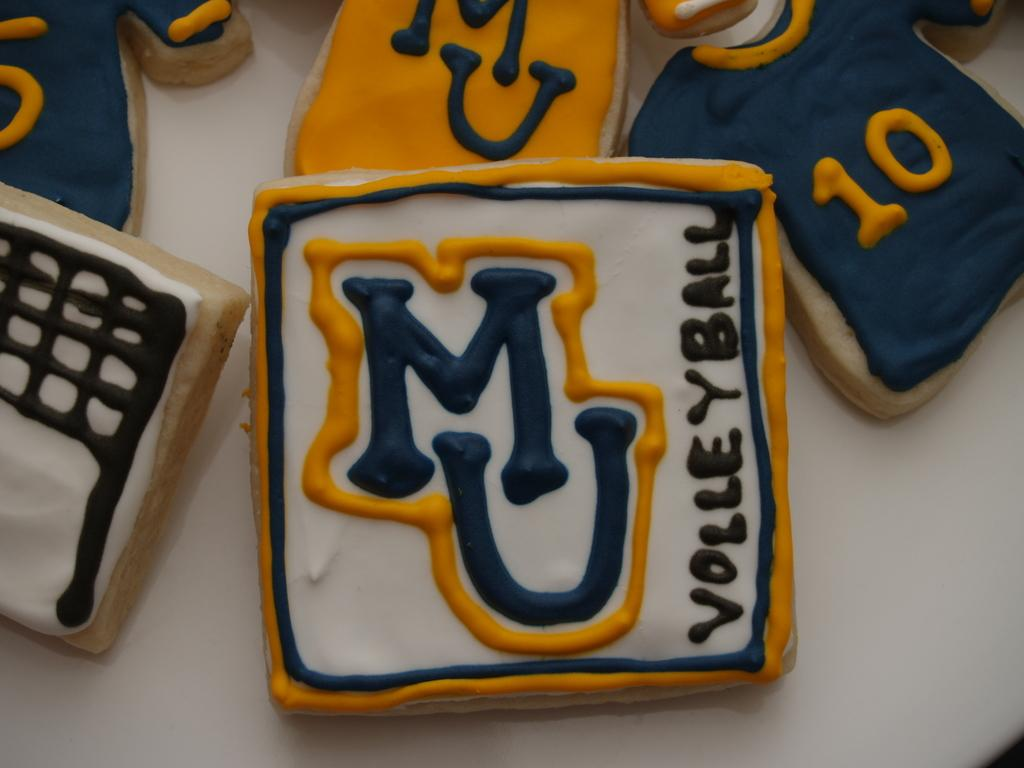Provide a one-sentence caption for the provided image. white, blue, and orange cookies celebrating MU VOlleyball. 